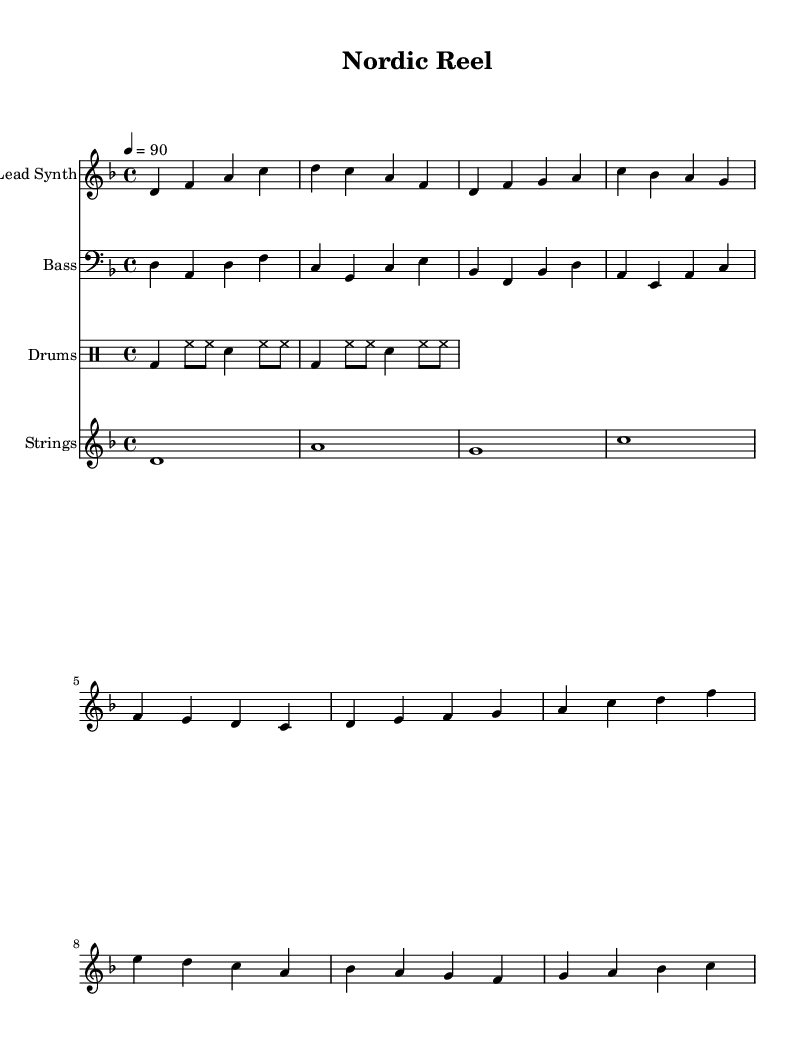What is the key signature of this music? The key signature is indicated at the beginning of the staff, which shows two flats. This corresponds to the key of D minor.
Answer: D minor What is the time signature of this music? The time signature can be found at the start of the score, represented by the fraction 4/4, which implies four beats per measure.
Answer: 4/4 What is the tempo marking for the piece? The tempo marking appears alongside the other notational elements, stating "4 = 90," which indicates the quarter note should be played at 90 beats per minute.
Answer: 90 What instrument is designated for the lead melody? The instrument name is specified at the beginning of the respective staff, which reads "Lead Synth" indicating that this staff is meant for a synthesizer sound.
Answer: Lead Synth How many sections are there in the music? By analyzing the provided musical data, we note distinct sections: an Intro, a Verse, and a Chorus, thus totaling three sections.
Answer: Three What rhythmic pattern is primarily used in the drums? The drum patterns consist predominantly of bass drum and hi-hat configurations, identified by the notation, with alternating measures of these instruments forming the primary rhythm.
Answer: Bass and hi-hat Which string note is played for the longest duration? The notation shows a whole note (d1) in the strings part, which is represented without stems; this note has the longest duration in the section.
Answer: D 